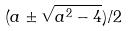Convert formula to latex. <formula><loc_0><loc_0><loc_500><loc_500>( a \pm \sqrt { a ^ { 2 } - 4 } ) / 2</formula> 